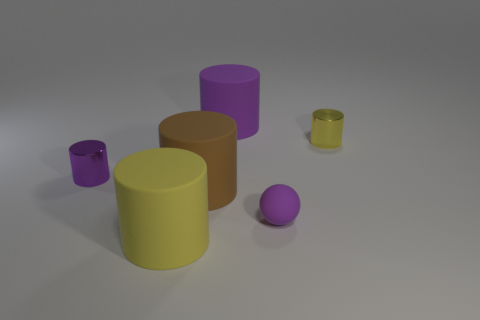Can you describe the lighting in the scene? Where might the light source be located based on the shadows? The lighting in the scene is soft and diffused, coming from the upper left side, as indicated by the shadows cast to the right side of the objects. 